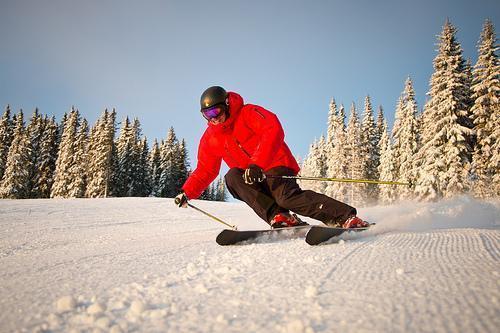How many people are in the picture?
Give a very brief answer. 1. 